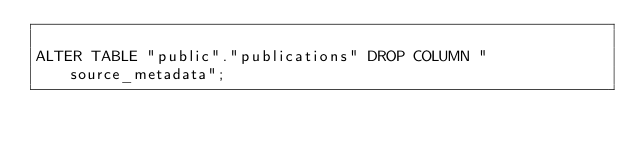Convert code to text. <code><loc_0><loc_0><loc_500><loc_500><_SQL_>
ALTER TABLE "public"."publications" DROP COLUMN "source_metadata";</code> 